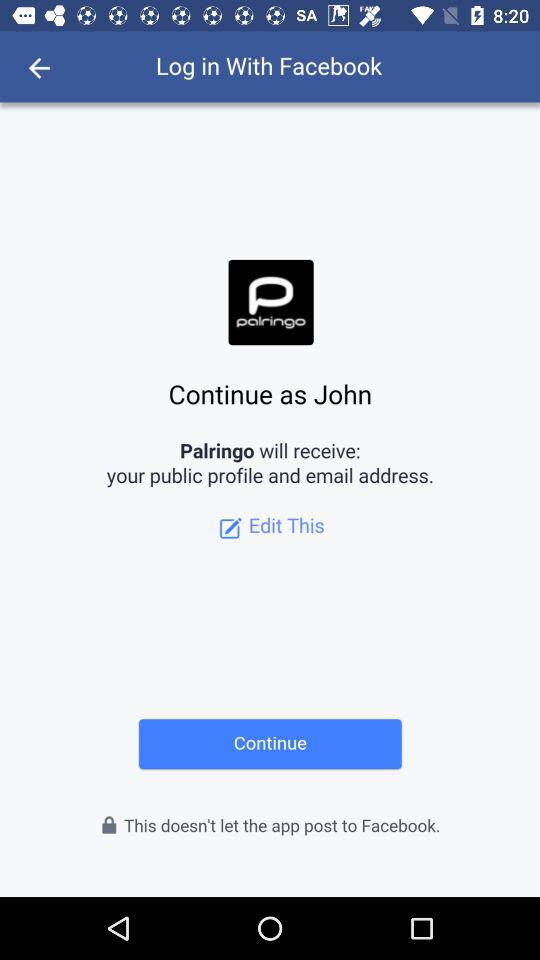What is the application by which we have logged in? The application is "Facebook". 